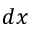<formula> <loc_0><loc_0><loc_500><loc_500>d x</formula> 